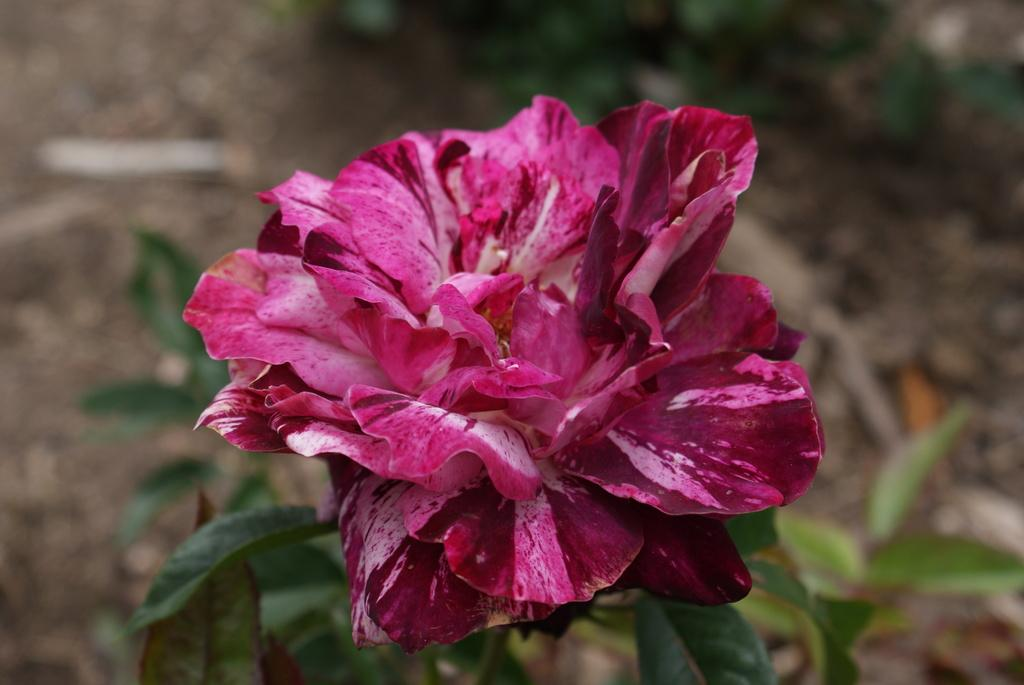What type of flora is present in the image? There is one flower and two plants in the image. Can you describe the arrangement of the flower and plants? The flower and plants are on a surface. What type of butter is being used to hold the flower and plants together in the image? There is no butter present in the image; the flower and plants are simply placed on a surface. How many strings are used to tie the flower and plants together in the image? There are no strings or any other visible means of tying the flower and plants together in the image. 